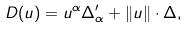Convert formula to latex. <formula><loc_0><loc_0><loc_500><loc_500>D ( { u } ) = u ^ { \alpha } \Delta ^ { \prime } _ { \alpha } + \| { u } \| \cdot \Delta ,</formula> 